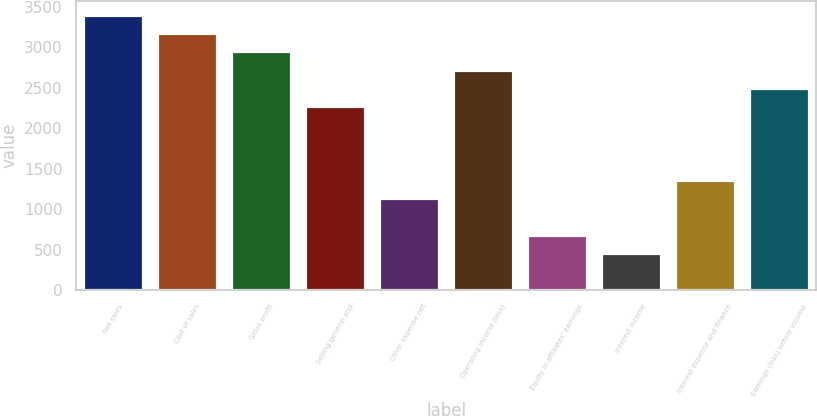Convert chart to OTSL. <chart><loc_0><loc_0><loc_500><loc_500><bar_chart><fcel>Net sales<fcel>Cost of sales<fcel>Gross profit<fcel>Selling general and<fcel>Other expense net<fcel>Operating income (loss)<fcel>Equity in affiliates' earnings<fcel>Interest income<fcel>Interest expense and finance<fcel>Earnings (loss) before income<nl><fcel>3402.51<fcel>3175.73<fcel>2948.95<fcel>2268.61<fcel>1134.66<fcel>2722.17<fcel>681.1<fcel>454.31<fcel>1361.45<fcel>2495.39<nl></chart> 